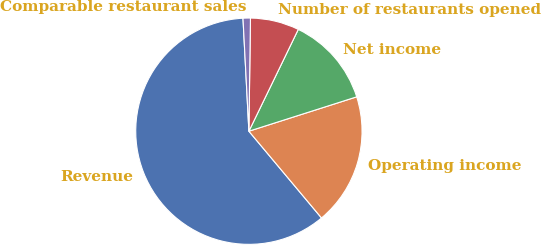<chart> <loc_0><loc_0><loc_500><loc_500><pie_chart><fcel>Revenue<fcel>Operating income<fcel>Net income<fcel>Number of restaurants opened<fcel>Comparable restaurant sales<nl><fcel>60.26%<fcel>18.82%<fcel>12.9%<fcel>6.97%<fcel>1.05%<nl></chart> 